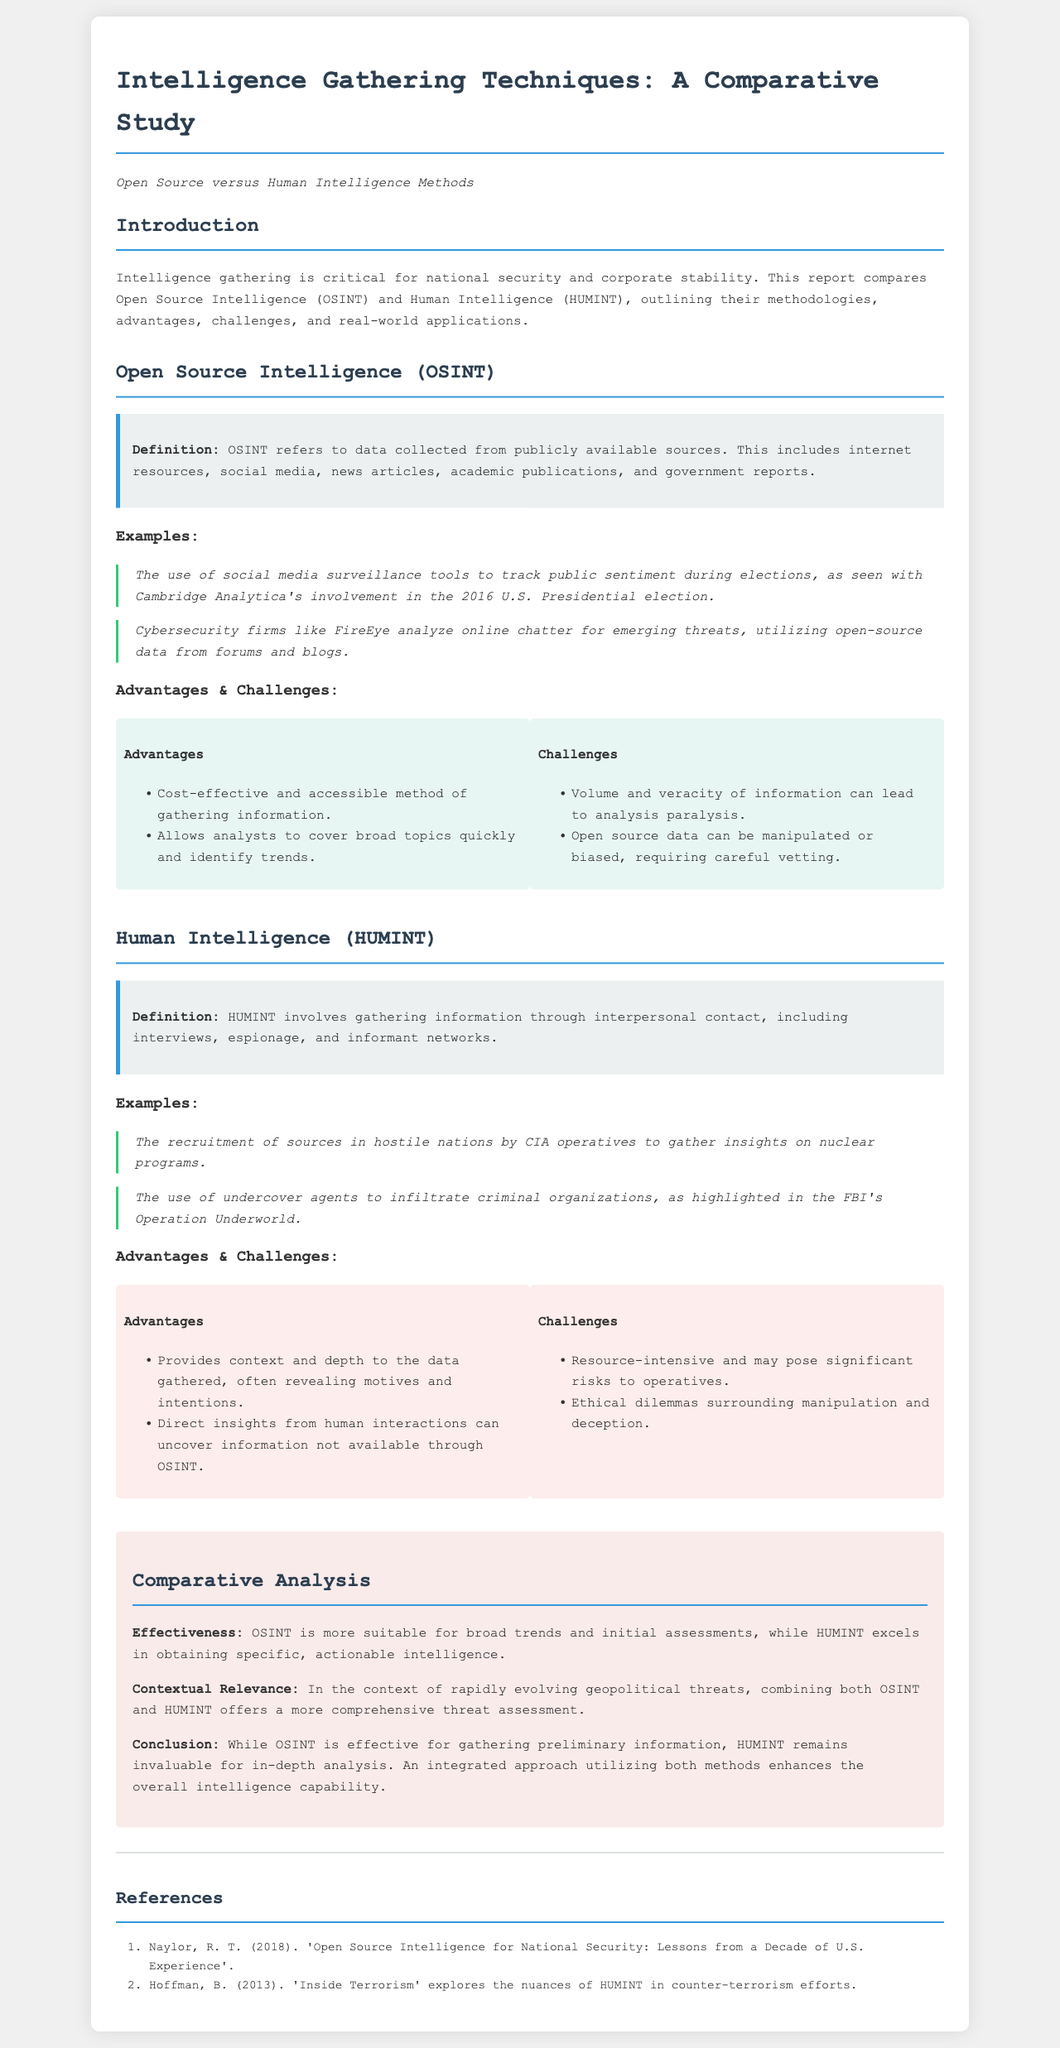What is the title of the report? The title of the report is explicitly stated in the document as "Intelligence Gathering Techniques: A Comparative Study."
Answer: Intelligence Gathering Techniques: A Comparative Study What are the two intelligence methods compared in the report? The two methods compared in the report are Open Source Intelligence and Human Intelligence.
Answer: Open Source Intelligence and Human Intelligence What is one example of OSINT provided in the report? An example of OSINT given in the report is the use of social media surveillance tools during elections.
Answer: The use of social media surveillance tools to track public sentiment during elections What is an advantage of HUMINT mentioned in the document? One advantage of HUMINT mentioned is that it provides context and depth to the data gathered.
Answer: Provides context and depth to the data gathered What is a challenge faced by OSINT according to the report? A challenge faced by OSINT is the volume and veracity of information.
Answer: Volume and veracity of information Which section outlines the advantages and challenges of OSINT? The section specifically discussing OSINT mentions both its advantages and challenges right after its definition.
Answer: The section on Open Source Intelligence (OSINT) How does the report conclude about the effectiveness of combining both methods? The report concludes that an integrated approach utilizing both methods enhances the overall intelligence capability.
Answer: Enhances the overall intelligence capability What is the primary focus of the introduction section? The introduction section primarily focuses on the importance of intelligence gathering for national security and corporate stability.
Answer: Importance of intelligence gathering for national security and corporate stability How many references are listed in the report? The report contains two references listed in the references section.
Answer: Two references 